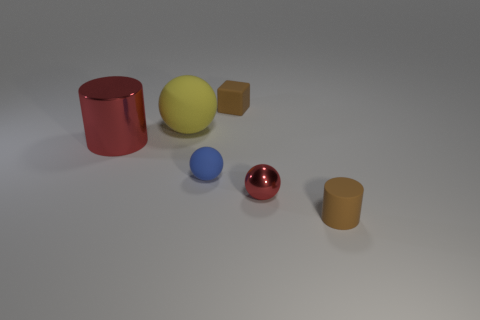Subtract all matte spheres. How many spheres are left? 1 Subtract all red spheres. How many spheres are left? 2 Subtract all purple spheres. Subtract all cyan cubes. How many spheres are left? 3 Subtract all blocks. How many objects are left? 5 Add 4 large green matte cubes. How many objects exist? 10 Subtract 0 red blocks. How many objects are left? 6 Subtract all small brown metallic objects. Subtract all spheres. How many objects are left? 3 Add 6 tiny metal spheres. How many tiny metal spheres are left? 7 Add 1 tiny matte cylinders. How many tiny matte cylinders exist? 2 